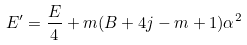Convert formula to latex. <formula><loc_0><loc_0><loc_500><loc_500>E ^ { \prime } = \frac { E } { 4 } + m ( B + 4 j - m + 1 ) \alpha ^ { 2 }</formula> 